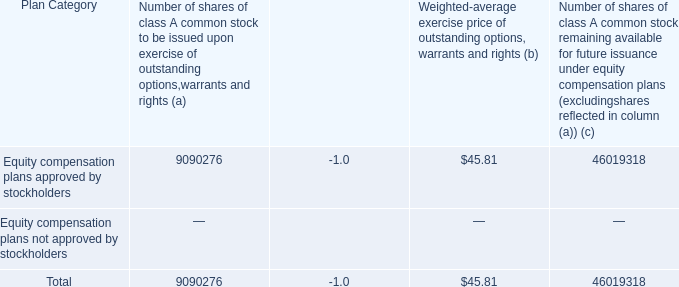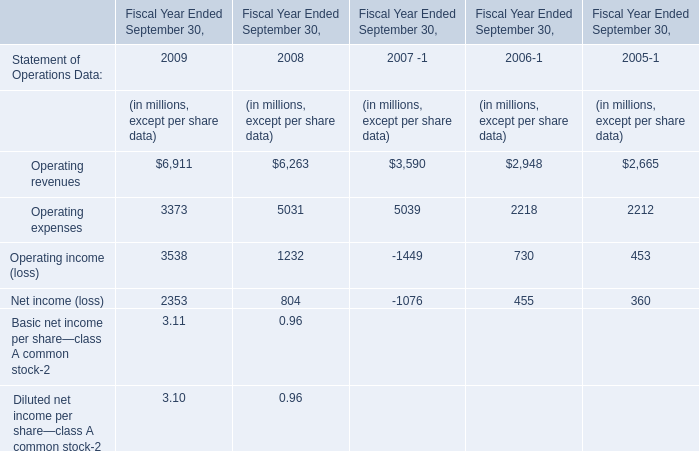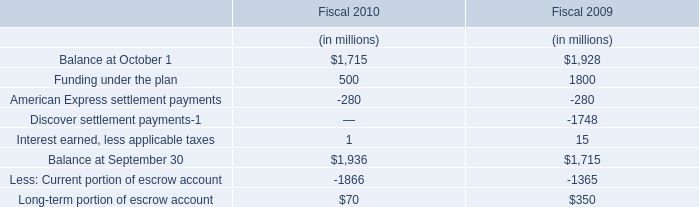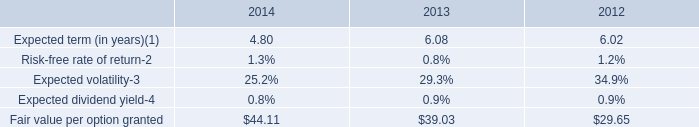What's the total value of all operations that are smaller than 4000 in 2009 (in million) 
Computations: ((3373 + 3538) + 2353)
Answer: 9264.0. 